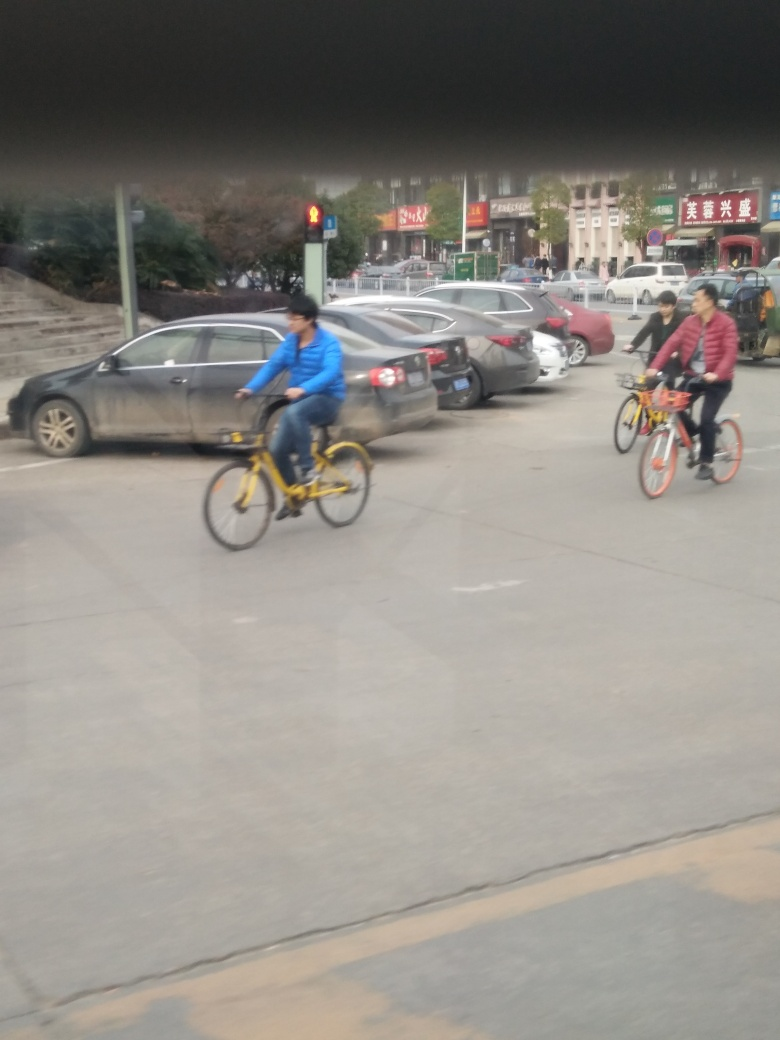What time of day does this image appear to be taken? The image seems to be taken during the daytime, as there is natural light and the sky is visible, although the exact time cannot be determined due to the absence of shadows. 